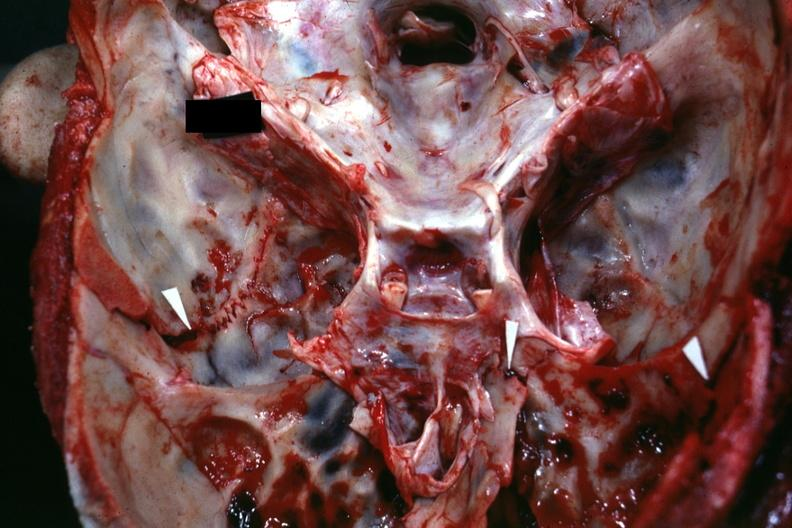what well shown fractures?
Answer the question using a single word or phrase. Close-up view of base of skull with several 